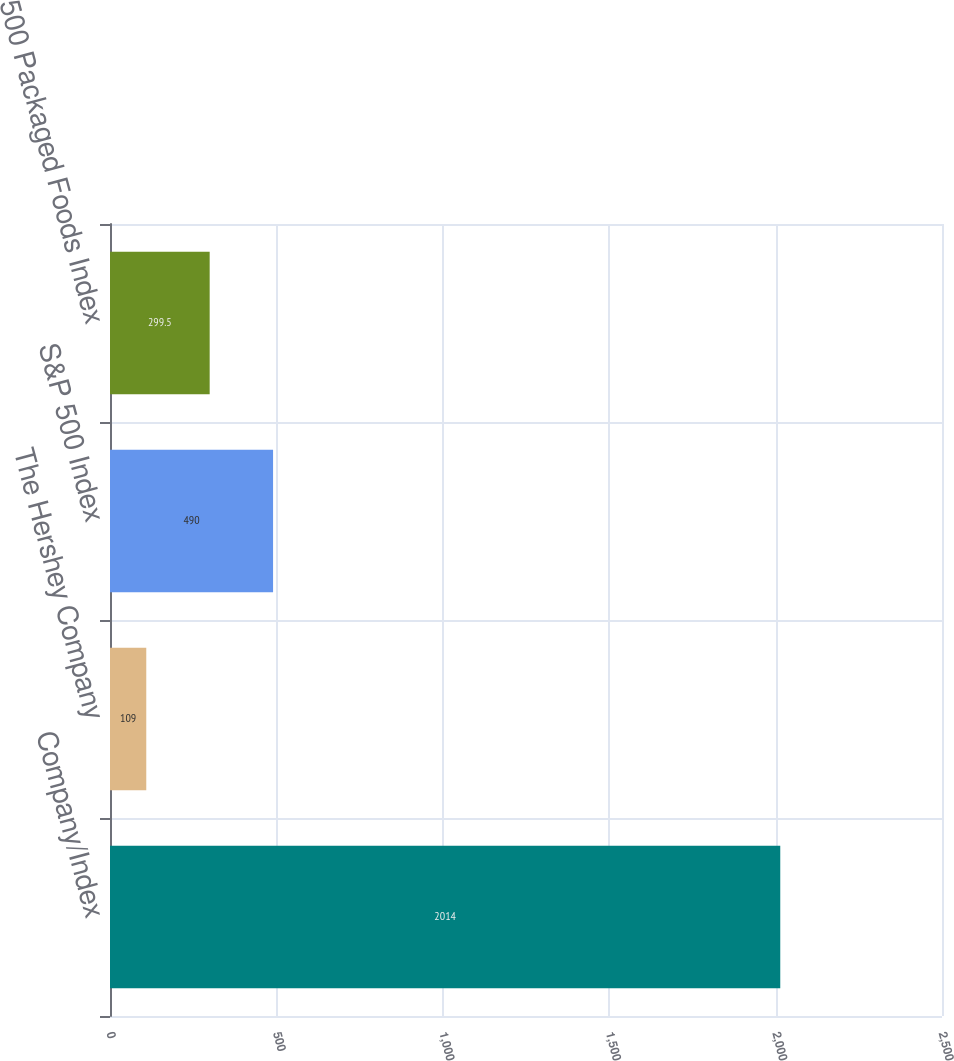<chart> <loc_0><loc_0><loc_500><loc_500><bar_chart><fcel>Company/Index<fcel>The Hershey Company<fcel>S&P 500 Index<fcel>S&P 500 Packaged Foods Index<nl><fcel>2014<fcel>109<fcel>490<fcel>299.5<nl></chart> 